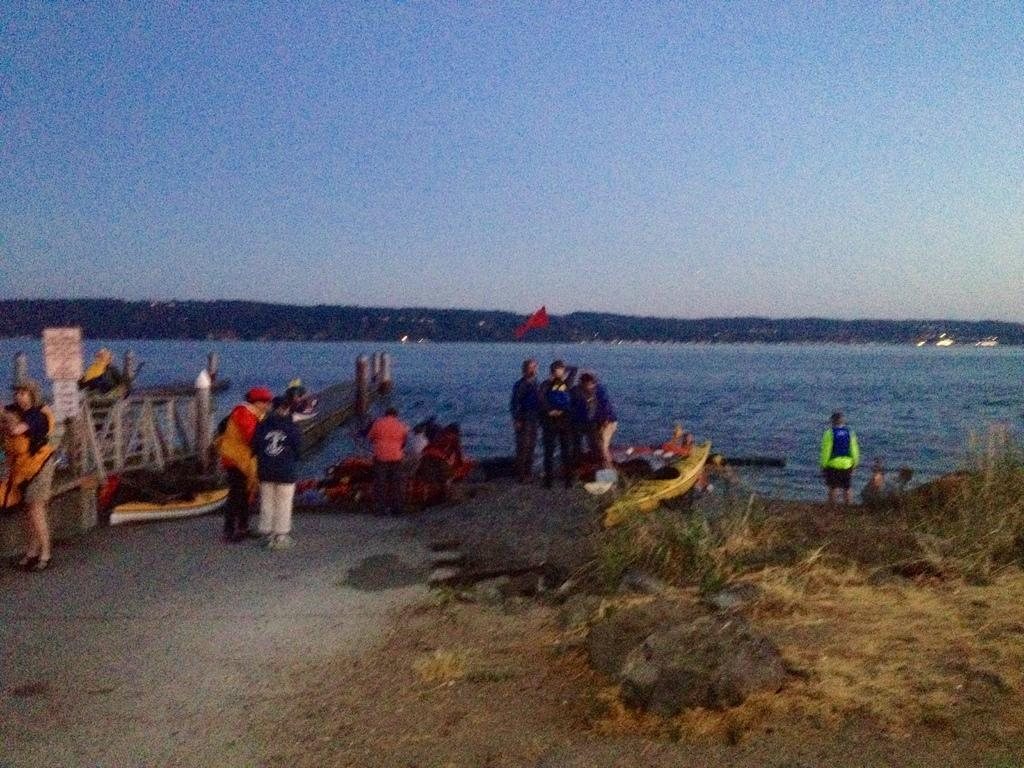What are the persons in the image doing? The persons in the image are on the road and on boats. Where are the boats located? The boats are on water, which is part of an ocean. What can be seen in the background of the image? There is a hill in the background. What is the color of the sky in the image? The sky is blue in the image. How many oranges are being used as oars by the persons on the boats? There are no oranges present in the image, and they are not being used as oars by the persons on the boats. What action is the town taking in the image? There is no town present in the image. The image features persons on the road and on boats in an ocean setting. 